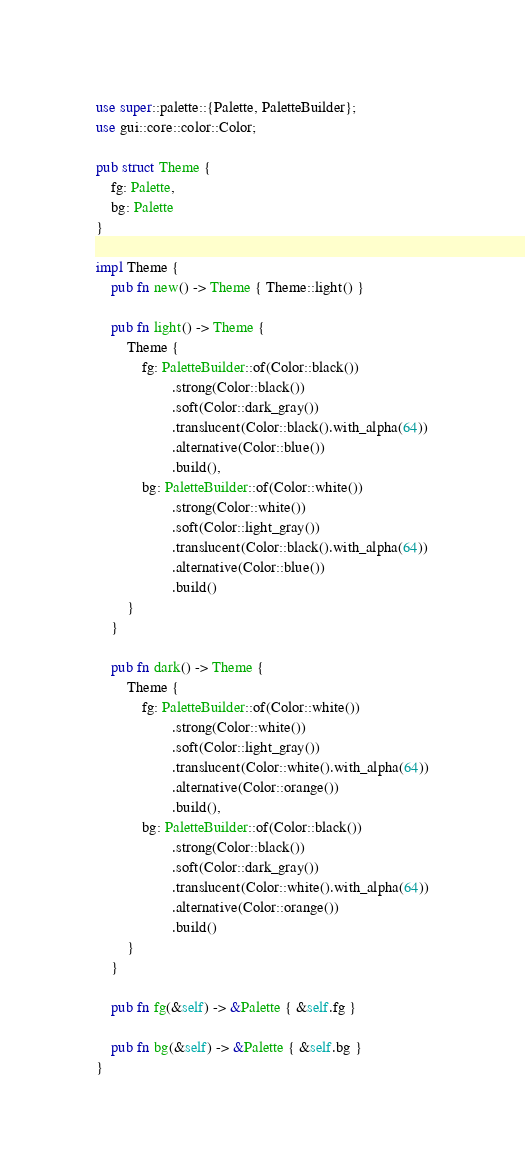<code> <loc_0><loc_0><loc_500><loc_500><_Rust_>use super::palette::{Palette, PaletteBuilder};
use gui::core::color::Color;

pub struct Theme {
	fg: Palette,
	bg: Palette
}

impl Theme {
	pub fn new() -> Theme { Theme::light() }
	
	pub fn light() -> Theme {
		Theme {
			fg: PaletteBuilder::of(Color::black())
					.strong(Color::black())
					.soft(Color::dark_gray())
					.translucent(Color::black().with_alpha(64))
					.alternative(Color::blue())
					.build(),
			bg: PaletteBuilder::of(Color::white())
					.strong(Color::white())
					.soft(Color::light_gray())
					.translucent(Color::black().with_alpha(64))
					.alternative(Color::blue())
					.build()
		}
	}
	
	pub fn dark() -> Theme {
		Theme {
			fg: PaletteBuilder::of(Color::white())
					.strong(Color::white())
					.soft(Color::light_gray())
					.translucent(Color::white().with_alpha(64))
					.alternative(Color::orange())
					.build(),
			bg: PaletteBuilder::of(Color::black())
					.strong(Color::black())
					.soft(Color::dark_gray())
					.translucent(Color::white().with_alpha(64))
					.alternative(Color::orange())
					.build()
		}
	}
	
	pub fn fg(&self) -> &Palette { &self.fg }
	
	pub fn bg(&self) -> &Palette { &self.bg }
}
</code> 